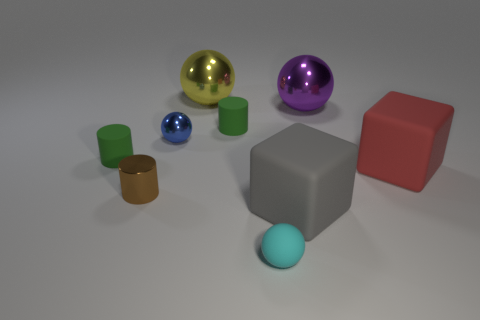What size is the blue thing that is the same shape as the purple shiny thing?
Your answer should be compact. Small. There is a gray object that is the same size as the yellow ball; what is it made of?
Offer a terse response. Rubber. There is a cyan object that is the same shape as the big yellow shiny thing; what material is it?
Your answer should be compact. Rubber. What number of other things are there of the same size as the purple metal sphere?
Provide a short and direct response. 3. What shape is the small brown metallic thing?
Offer a very short reply. Cylinder. What color is the large object that is in front of the purple metal ball and to the left of the big red block?
Make the answer very short. Gray. What material is the small cyan ball?
Your response must be concise. Rubber. What shape is the green object on the left side of the large yellow metallic object?
Make the answer very short. Cylinder. What color is the other sphere that is the same size as the yellow sphere?
Offer a very short reply. Purple. Is the material of the gray object that is right of the tiny blue metal object the same as the tiny cyan ball?
Your answer should be compact. Yes. 